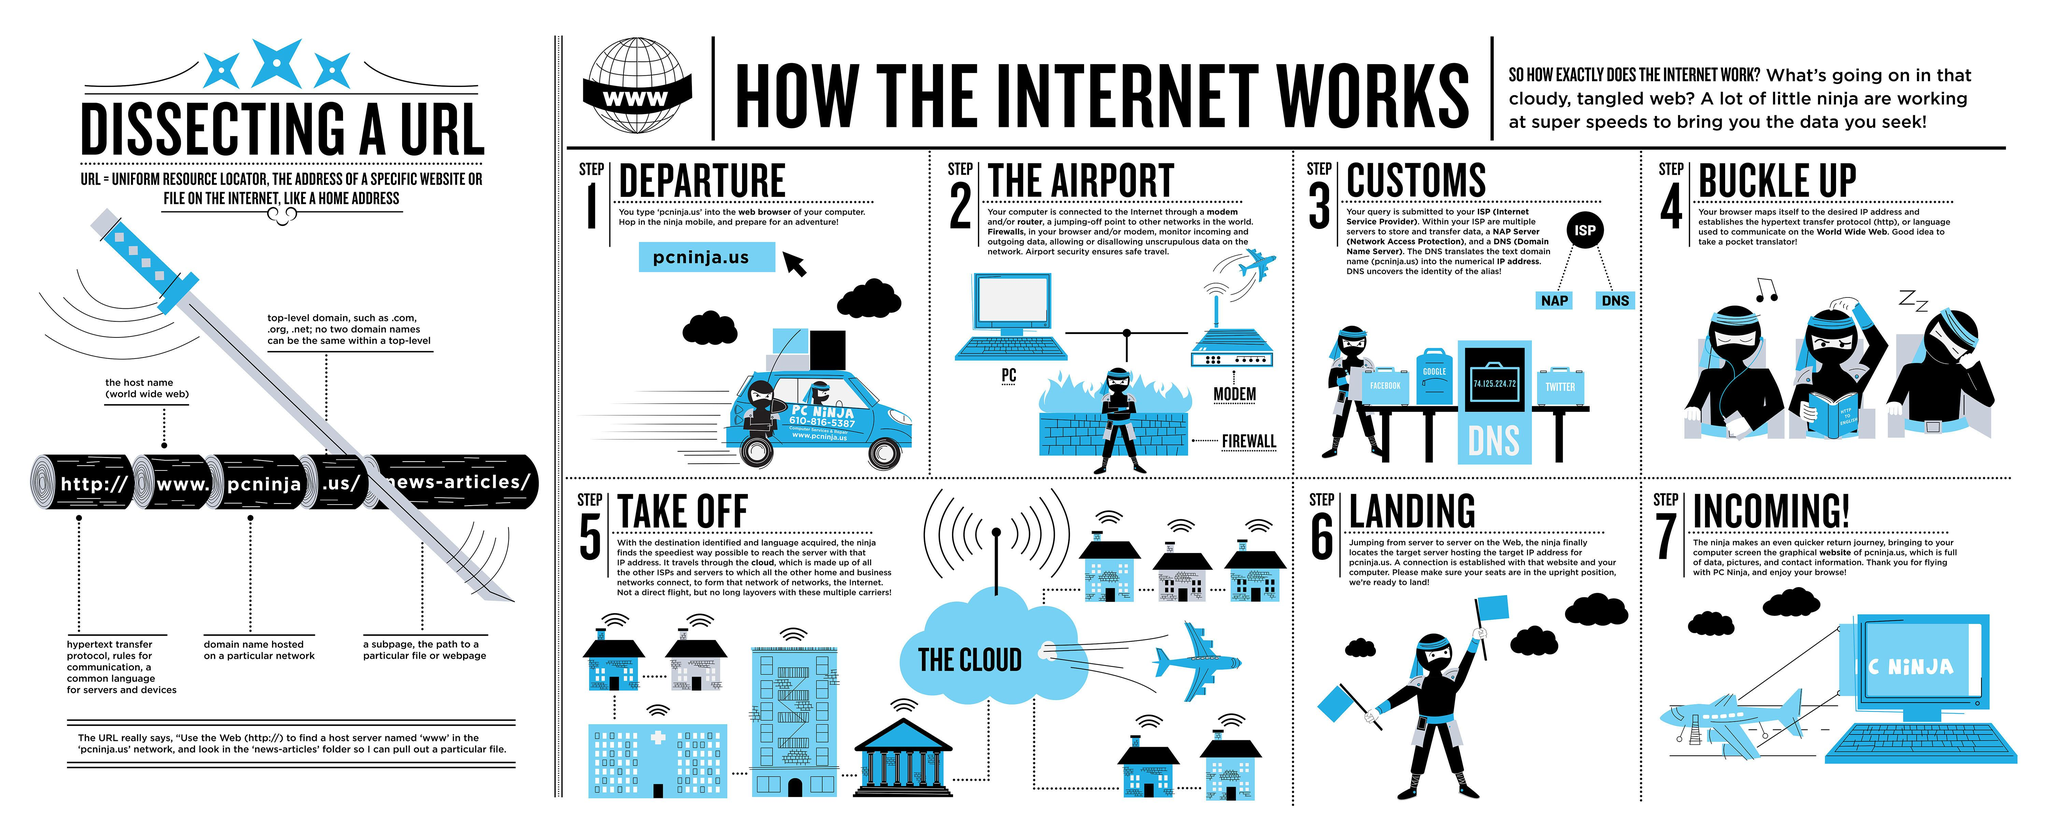Identify some key points in this picture. The social media platforms depicted in step 3 images include Facebook, Google, and Twitter. The "www" in a URL represents the hostname of the website, which is the World Wide Web. 